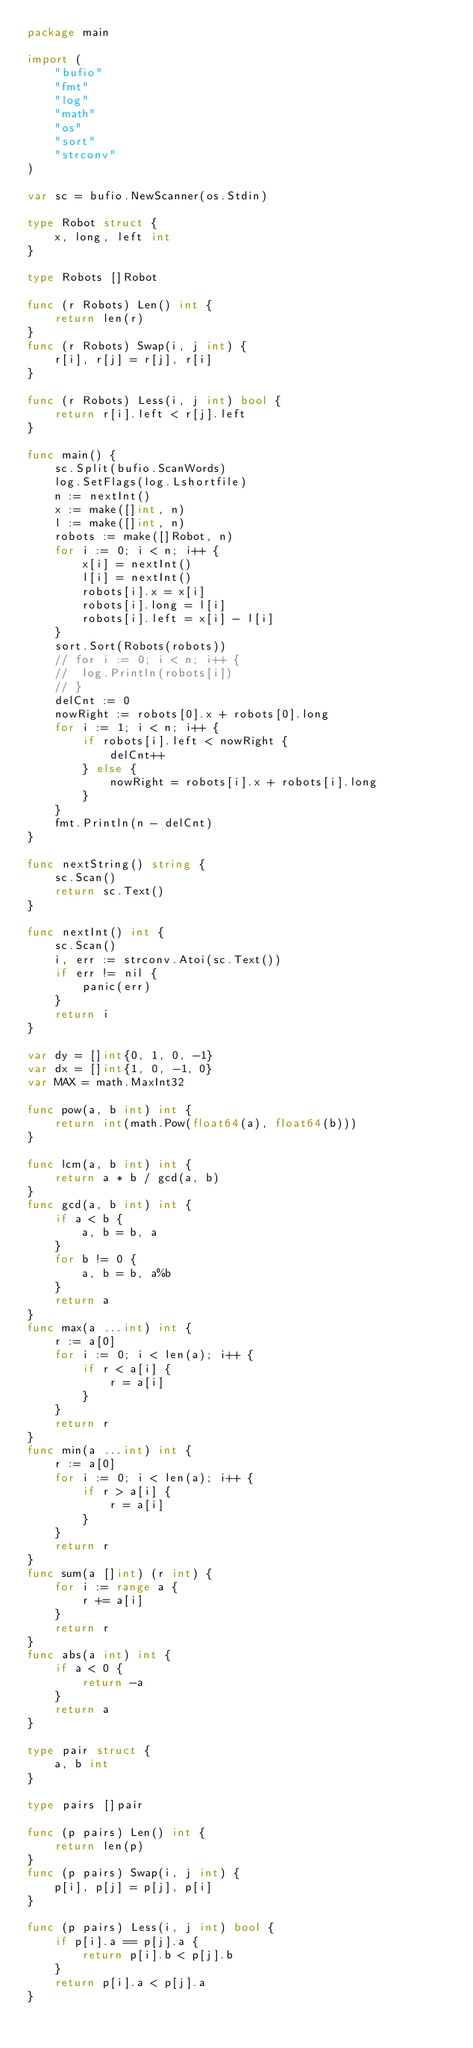<code> <loc_0><loc_0><loc_500><loc_500><_Go_>package main

import (
	"bufio"
	"fmt"
	"log"
	"math"
	"os"
	"sort"
	"strconv"
)

var sc = bufio.NewScanner(os.Stdin)

type Robot struct {
	x, long, left int
}

type Robots []Robot

func (r Robots) Len() int {
	return len(r)
}
func (r Robots) Swap(i, j int) {
	r[i], r[j] = r[j], r[i]
}

func (r Robots) Less(i, j int) bool {
	return r[i].left < r[j].left
}

func main() {
	sc.Split(bufio.ScanWords)
	log.SetFlags(log.Lshortfile)
	n := nextInt()
	x := make([]int, n)
	l := make([]int, n)
	robots := make([]Robot, n)
	for i := 0; i < n; i++ {
		x[i] = nextInt()
		l[i] = nextInt()
		robots[i].x = x[i]
		robots[i].long = l[i]
		robots[i].left = x[i] - l[i]
	}
	sort.Sort(Robots(robots))
	// for i := 0; i < n; i++ {
	// 	log.Println(robots[i])
	// }
	delCnt := 0
	nowRight := robots[0].x + robots[0].long
	for i := 1; i < n; i++ {
		if robots[i].left < nowRight {
			delCnt++
		} else {
			nowRight = robots[i].x + robots[i].long
		}
	}
	fmt.Println(n - delCnt)
}

func nextString() string {
	sc.Scan()
	return sc.Text()
}

func nextInt() int {
	sc.Scan()
	i, err := strconv.Atoi(sc.Text())
	if err != nil {
		panic(err)
	}
	return i
}

var dy = []int{0, 1, 0, -1}
var dx = []int{1, 0, -1, 0}
var MAX = math.MaxInt32

func pow(a, b int) int {
	return int(math.Pow(float64(a), float64(b)))
}

func lcm(a, b int) int {
	return a * b / gcd(a, b)
}
func gcd(a, b int) int {
	if a < b {
		a, b = b, a
	}
	for b != 0 {
		a, b = b, a%b
	}
	return a
}
func max(a ...int) int {
	r := a[0]
	for i := 0; i < len(a); i++ {
		if r < a[i] {
			r = a[i]
		}
	}
	return r
}
func min(a ...int) int {
	r := a[0]
	for i := 0; i < len(a); i++ {
		if r > a[i] {
			r = a[i]
		}
	}
	return r
}
func sum(a []int) (r int) {
	for i := range a {
		r += a[i]
	}
	return r
}
func abs(a int) int {
	if a < 0 {
		return -a
	}
	return a
}

type pair struct {
	a, b int
}

type pairs []pair

func (p pairs) Len() int {
	return len(p)
}
func (p pairs) Swap(i, j int) {
	p[i], p[j] = p[j], p[i]
}

func (p pairs) Less(i, j int) bool {
	if p[i].a == p[j].a {
		return p[i].b < p[j].b
	}
	return p[i].a < p[j].a
}
</code> 